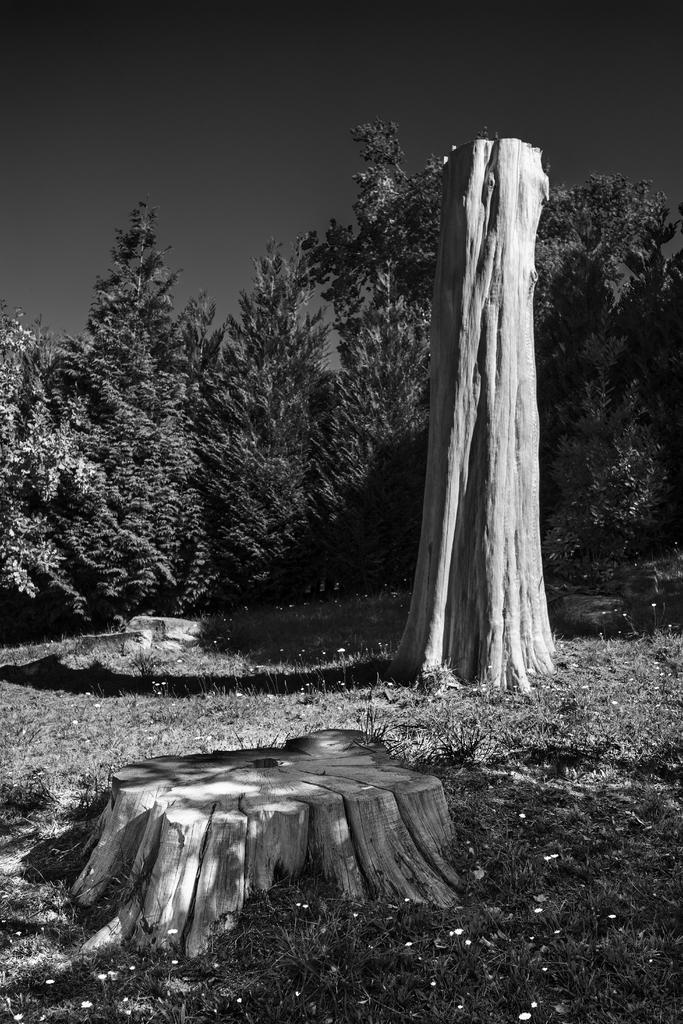Please provide a concise description of this image. In this image I can see tree trunks, grass, shadows and number of trees. I can also see this image is black and white in colour. 